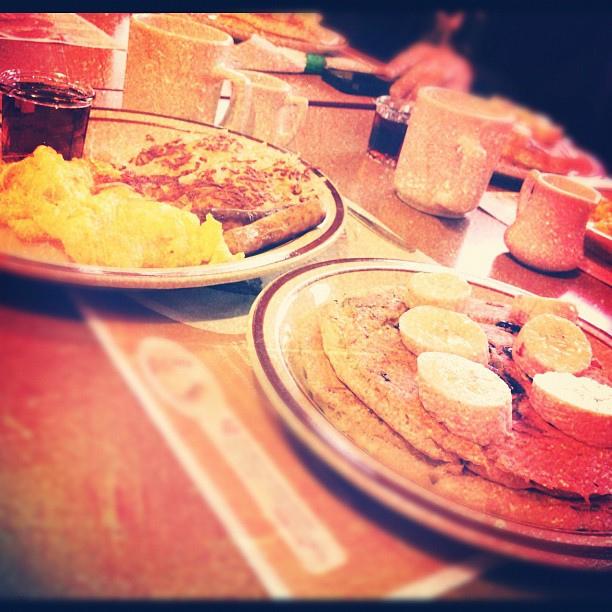How many banana slices are there?
Give a very brief answer. 6. Are there eggs on the plate?
Be succinct. Yes. Is this a meal?
Short answer required. Yes. What are the pancakes topped with?
Concise answer only. Bananas. 